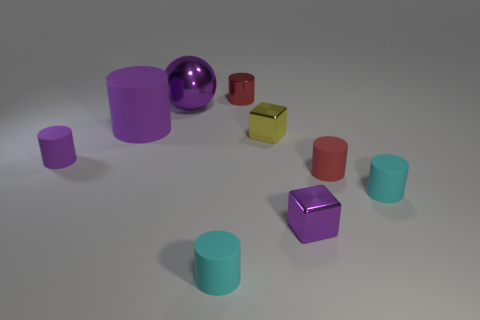Which object stands out the most to you and why? The object that stands out the most is the shiny purple sphere. Its reflective surface catches the light and provides a stark contrast to the more subdued, matte textures of the other objects. Furthermore, its spherical shape differs from the predominantly cylindrical and cubical forms in the scene, making it a focal point amongst the assortment of shapes. 